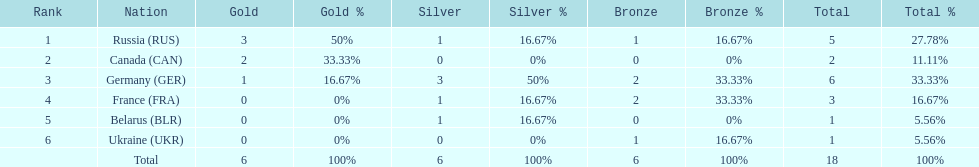Which country won more total medals than tue french, but less than the germans in the 1994 winter olympic biathlon? Russia. 